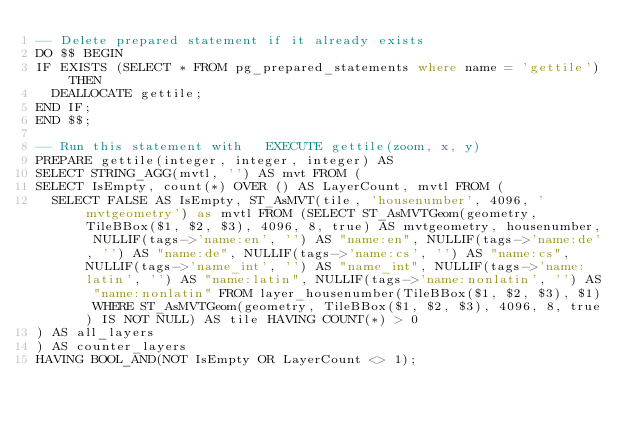<code> <loc_0><loc_0><loc_500><loc_500><_SQL_>-- Delete prepared statement if it already exists
DO $$ BEGIN
IF EXISTS (SELECT * FROM pg_prepared_statements where name = 'gettile') THEN
  DEALLOCATE gettile;
END IF;
END $$;

-- Run this statement with   EXECUTE gettile(zoom, x, y)
PREPARE gettile(integer, integer, integer) AS
SELECT STRING_AGG(mvtl, '') AS mvt FROM (
SELECT IsEmpty, count(*) OVER () AS LayerCount, mvtl FROM (
  SELECT FALSE AS IsEmpty, ST_AsMVT(tile, 'housenumber', 4096, 'mvtgeometry') as mvtl FROM (SELECT ST_AsMVTGeom(geometry, TileBBox($1, $2, $3), 4096, 8, true) AS mvtgeometry, housenumber, NULLIF(tags->'name:en', '') AS "name:en", NULLIF(tags->'name:de', '') AS "name:de", NULLIF(tags->'name:cs', '') AS "name:cs", NULLIF(tags->'name_int', '') AS "name_int", NULLIF(tags->'name:latin', '') AS "name:latin", NULLIF(tags->'name:nonlatin', '') AS "name:nonlatin" FROM layer_housenumber(TileBBox($1, $2, $3), $1) WHERE ST_AsMVTGeom(geometry, TileBBox($1, $2, $3), 4096, 8, true) IS NOT NULL) AS tile HAVING COUNT(*) > 0
) AS all_layers
) AS counter_layers
HAVING BOOL_AND(NOT IsEmpty OR LayerCount <> 1);
</code> 